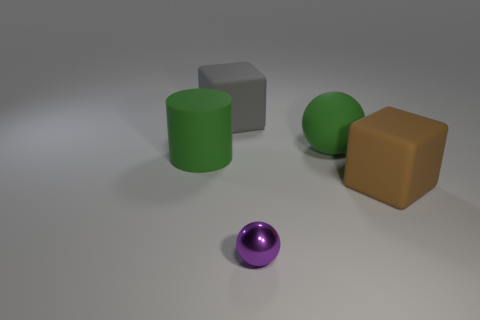Subtract all gray blocks. How many blocks are left? 1 Add 3 balls. How many objects exist? 8 Subtract all balls. How many objects are left? 3 Subtract 1 blocks. How many blocks are left? 1 Subtract 0 blue cylinders. How many objects are left? 5 Subtract all gray blocks. Subtract all brown spheres. How many blocks are left? 1 Subtract all big green matte objects. Subtract all balls. How many objects are left? 1 Add 1 large gray matte objects. How many large gray matte objects are left? 2 Add 5 tiny green things. How many tiny green things exist? 5 